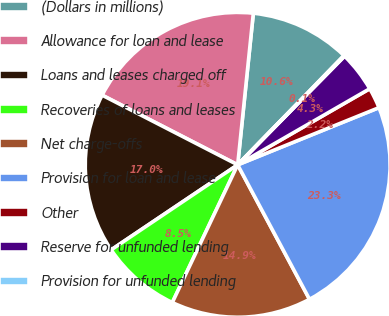Convert chart. <chart><loc_0><loc_0><loc_500><loc_500><pie_chart><fcel>(Dollars in millions)<fcel>Allowance for loan and lease<fcel>Loans and leases charged off<fcel>Recoveries of loans and leases<fcel>Net charge-offs<fcel>Provision for loan and lease<fcel>Other<fcel>Reserve for unfunded lending<fcel>Provision for unfunded lending<nl><fcel>10.64%<fcel>19.08%<fcel>16.97%<fcel>8.53%<fcel>14.86%<fcel>23.31%<fcel>2.2%<fcel>4.31%<fcel>0.09%<nl></chart> 